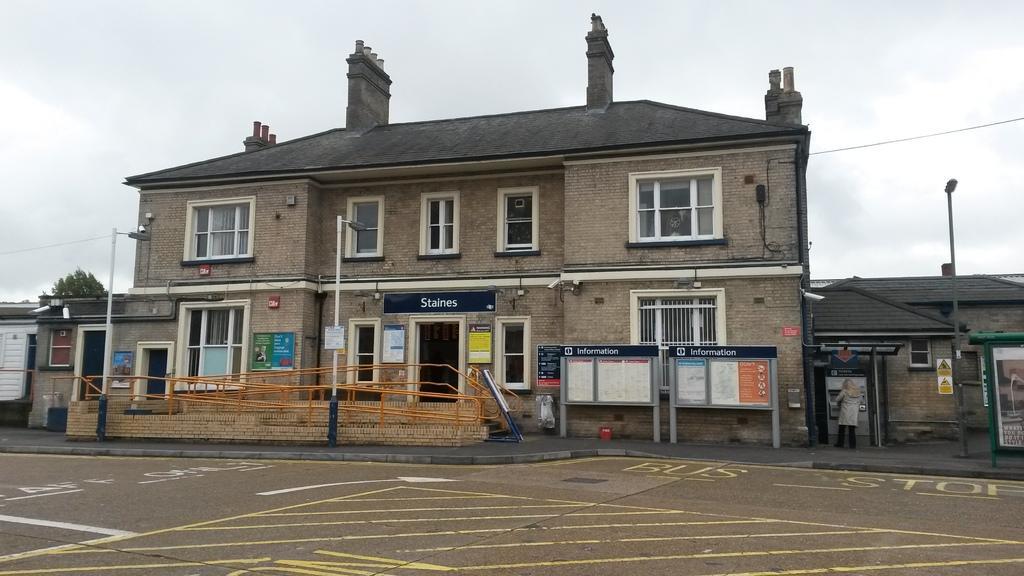How would you summarize this image in a sentence or two? In this image we can see few buildings with doors and windows and there are some boards with the text and we can see few street lights. There is a person standing on the right side of the image and there is a tree in the background and at the top we can see the sky. 